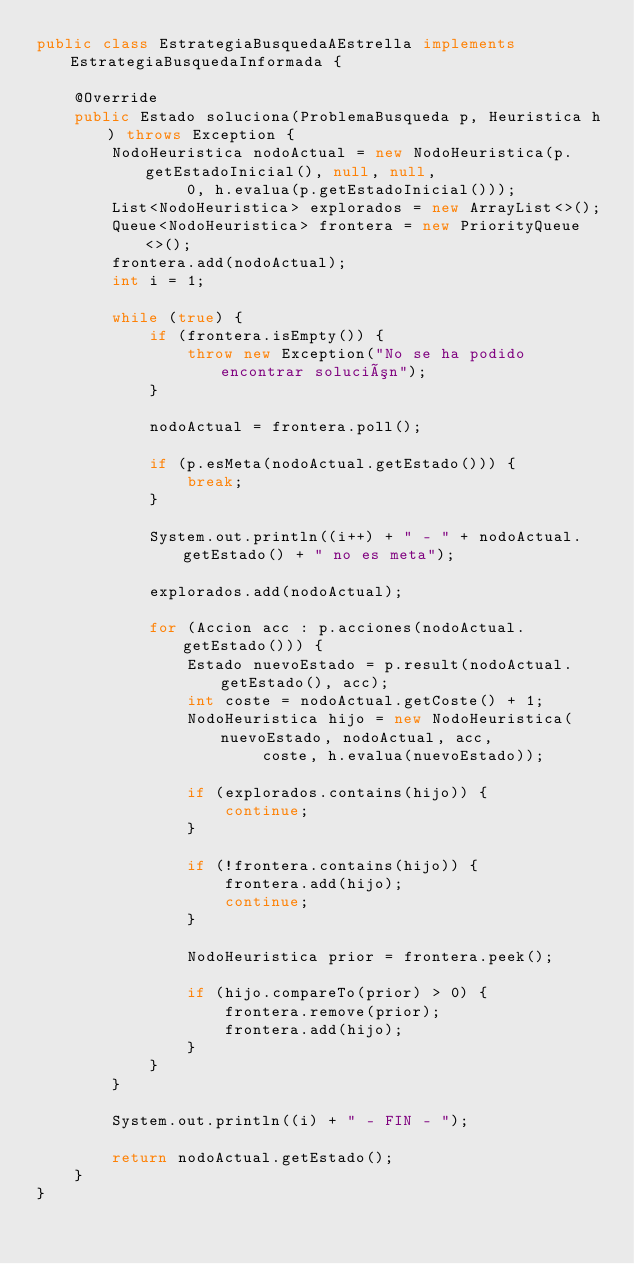Convert code to text. <code><loc_0><loc_0><loc_500><loc_500><_Java_>public class EstrategiaBusquedaAEstrella implements EstrategiaBusquedaInformada {

    @Override
    public Estado soluciona(ProblemaBusqueda p, Heuristica h) throws Exception {
        NodoHeuristica nodoActual = new NodoHeuristica(p.getEstadoInicial(), null, null,
                0, h.evalua(p.getEstadoInicial()));
        List<NodoHeuristica> explorados = new ArrayList<>();
        Queue<NodoHeuristica> frontera = new PriorityQueue<>();
        frontera.add(nodoActual);
        int i = 1;

        while (true) {
            if (frontera.isEmpty()) {
                throw new Exception("No se ha podido encontrar solución");
            }

            nodoActual = frontera.poll();

            if (p.esMeta(nodoActual.getEstado())) {
                break;
            }

            System.out.println((i++) + " - " + nodoActual.getEstado() + " no es meta");

            explorados.add(nodoActual);

            for (Accion acc : p.acciones(nodoActual.getEstado())) {
                Estado nuevoEstado = p.result(nodoActual.getEstado(), acc);
                int coste = nodoActual.getCoste() + 1;
                NodoHeuristica hijo = new NodoHeuristica(nuevoEstado, nodoActual, acc,
                        coste, h.evalua(nuevoEstado));

                if (explorados.contains(hijo)) {
                    continue;
                }

                if (!frontera.contains(hijo)) {
                    frontera.add(hijo);
                    continue;
                }

                NodoHeuristica prior = frontera.peek();

                if (hijo.compareTo(prior) > 0) {
                    frontera.remove(prior);
                    frontera.add(hijo);
                }
            }
        }

        System.out.println((i) + " - FIN - ");

        return nodoActual.getEstado();
    }
}
</code> 